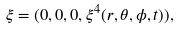<formula> <loc_0><loc_0><loc_500><loc_500>\xi = ( 0 , 0 , 0 , \xi ^ { 4 } ( r , \theta , \phi , t ) ) ,</formula> 